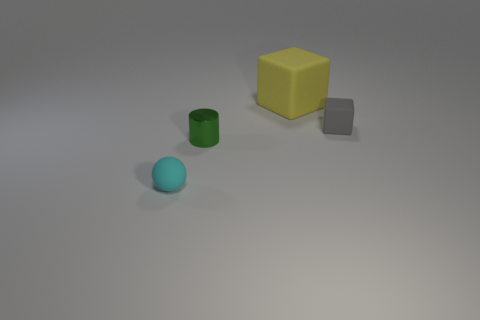How many things are rubber spheres or small rubber objects right of the large yellow matte block?
Ensure brevity in your answer.  2. What is the small block made of?
Your response must be concise. Rubber. There is a small matte object in front of the small object that is right of the yellow rubber object; what is its color?
Provide a short and direct response. Cyan. How many metal objects are either gray things or large cubes?
Your answer should be compact. 0. Does the gray block have the same material as the large yellow thing?
Offer a terse response. Yes. What material is the cube that is to the left of the cube that is in front of the large cube made of?
Make the answer very short. Rubber. What number of large things are matte balls or red rubber spheres?
Your answer should be compact. 0. What size is the yellow rubber cube?
Provide a short and direct response. Large. Is the number of things right of the tiny cyan matte sphere greater than the number of tiny metal cylinders?
Your answer should be compact. Yes. Are there an equal number of tiny gray things that are on the right side of the tiny gray matte block and tiny gray objects that are right of the large yellow matte cube?
Your response must be concise. No. 